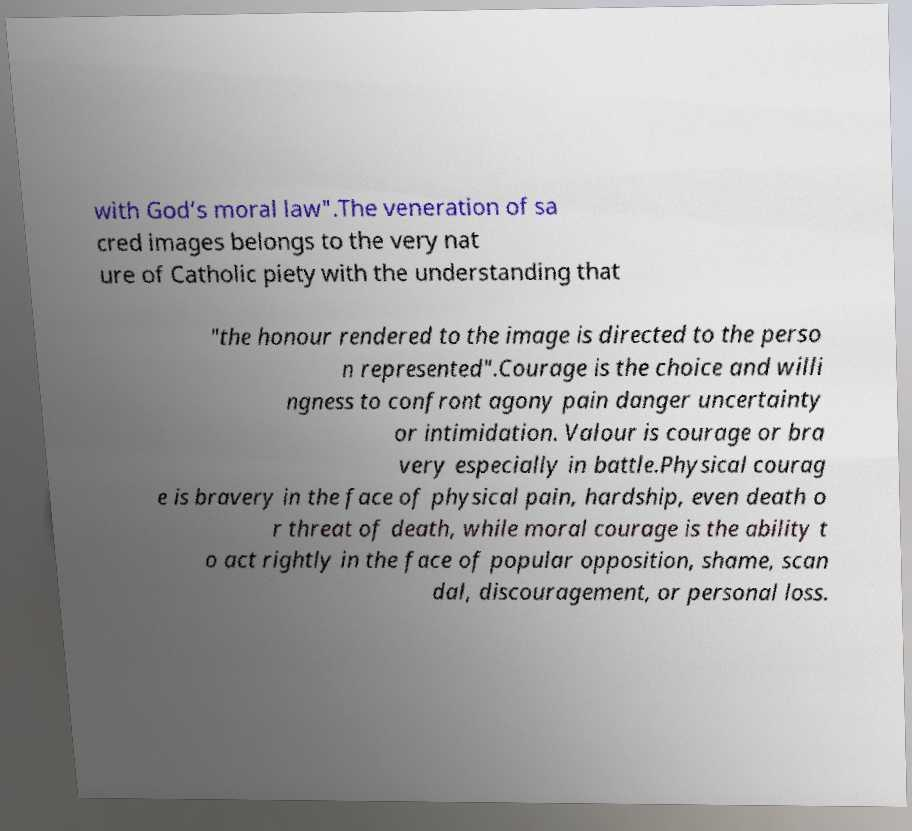Can you read and provide the text displayed in the image?This photo seems to have some interesting text. Can you extract and type it out for me? with God’s moral law".The veneration of sa cred images belongs to the very nat ure of Catholic piety with the understanding that "the honour rendered to the image is directed to the perso n represented".Courage is the choice and willi ngness to confront agony pain danger uncertainty or intimidation. Valour is courage or bra very especially in battle.Physical courag e is bravery in the face of physical pain, hardship, even death o r threat of death, while moral courage is the ability t o act rightly in the face of popular opposition, shame, scan dal, discouragement, or personal loss. 